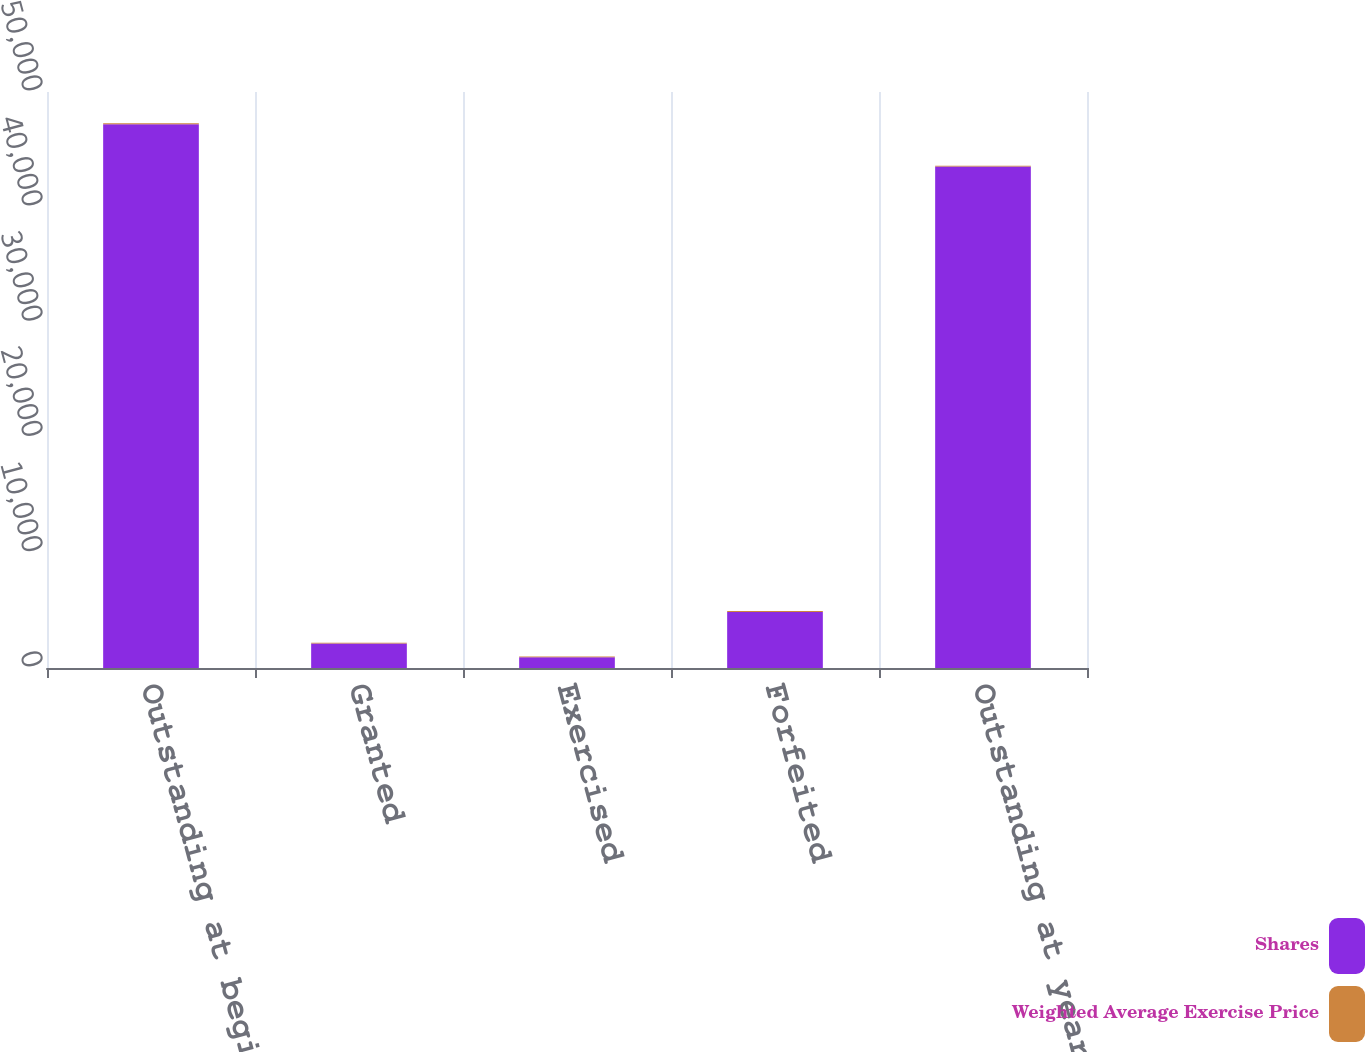Convert chart. <chart><loc_0><loc_0><loc_500><loc_500><stacked_bar_chart><ecel><fcel>Outstanding at beginning of<fcel>Granted<fcel>Exercised<fcel>Forfeited<fcel>Outstanding at year-end<nl><fcel>Shares<fcel>47210<fcel>2121<fcel>936<fcel>4866<fcel>43529<nl><fcel>Weighted Average Exercise Price<fcel>79.13<fcel>76.95<fcel>54.2<fcel>84.19<fcel>79.36<nl></chart> 